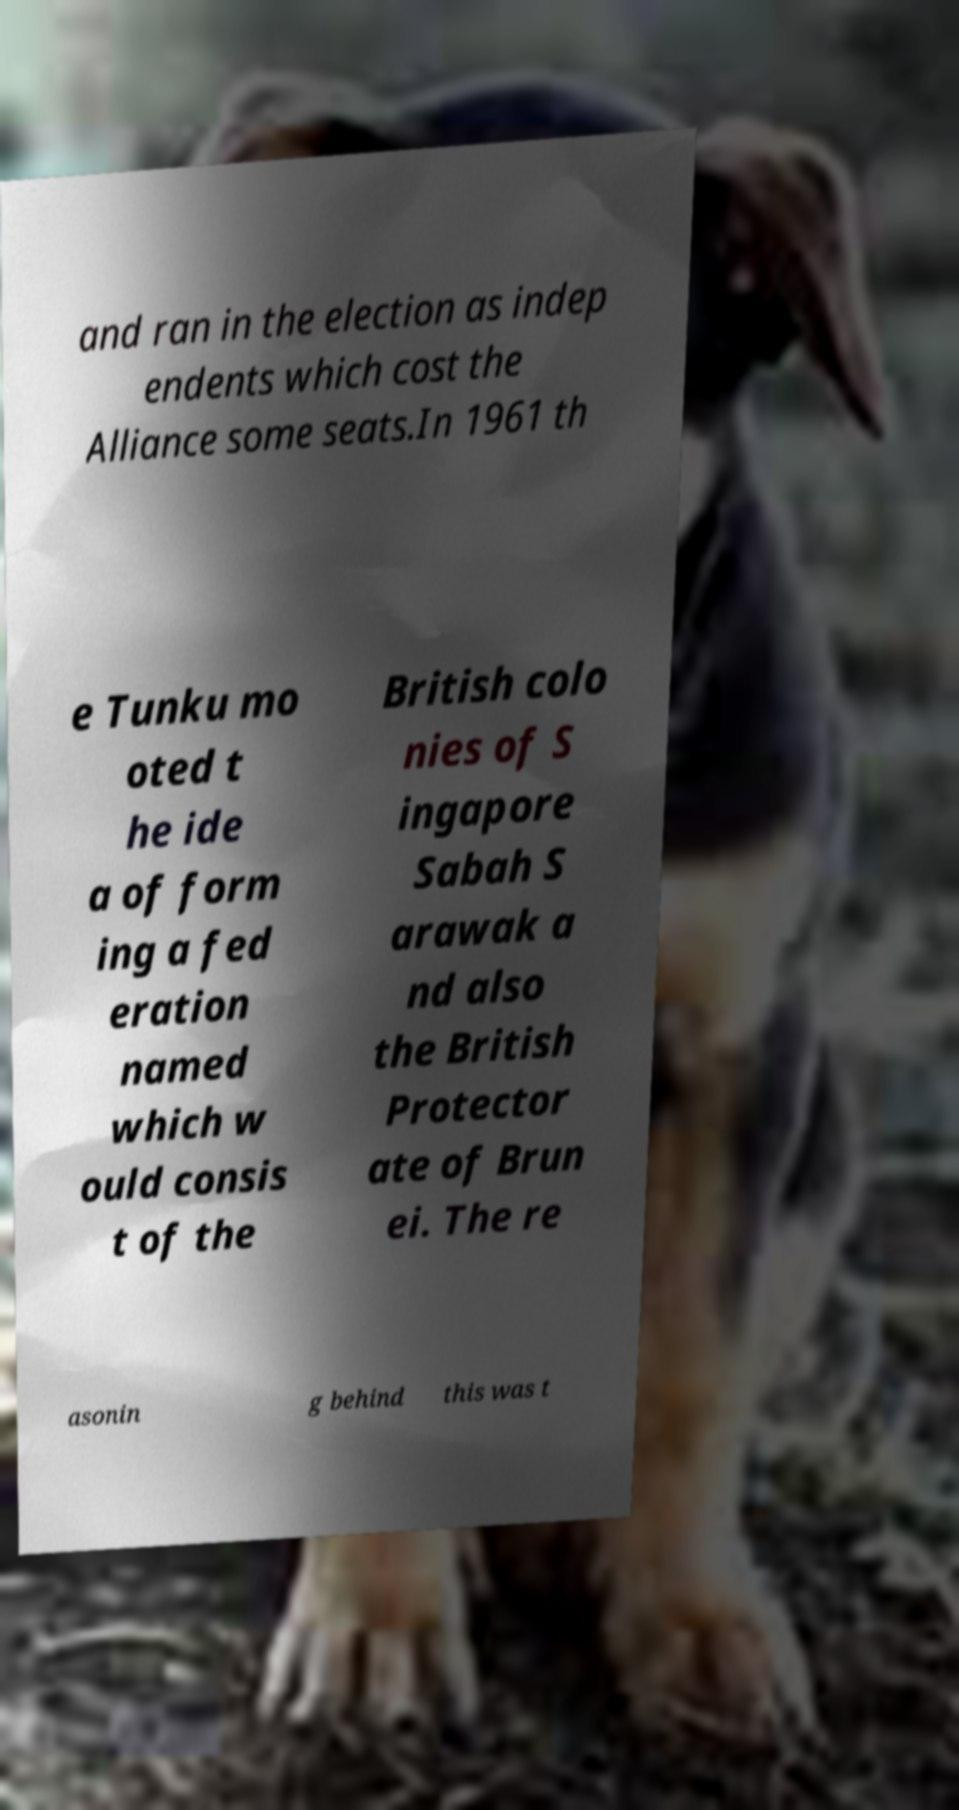Could you assist in decoding the text presented in this image and type it out clearly? and ran in the election as indep endents which cost the Alliance some seats.In 1961 th e Tunku mo oted t he ide a of form ing a fed eration named which w ould consis t of the British colo nies of S ingapore Sabah S arawak a nd also the British Protector ate of Brun ei. The re asonin g behind this was t 